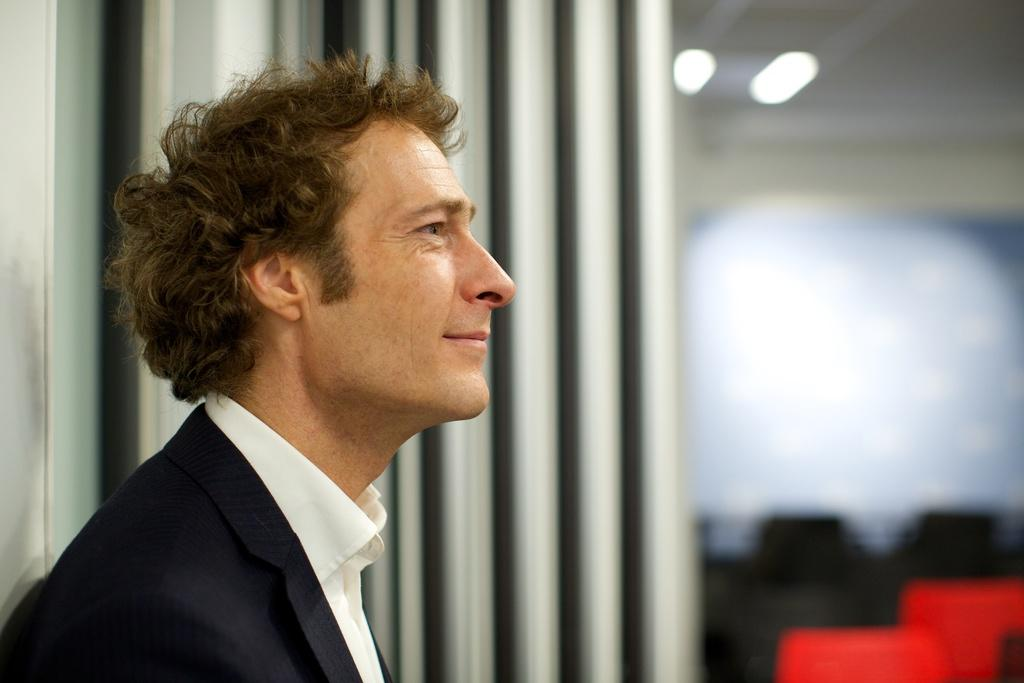What is the main subject of the image? There is a person standing in the image. In which direction is the person facing? The person is facing towards the right. Can you describe the background of the image? The background of the image is blurred. What type of texture can be seen on the clover in the image? There is no clover present in the image, so it is not possible to determine its texture. 